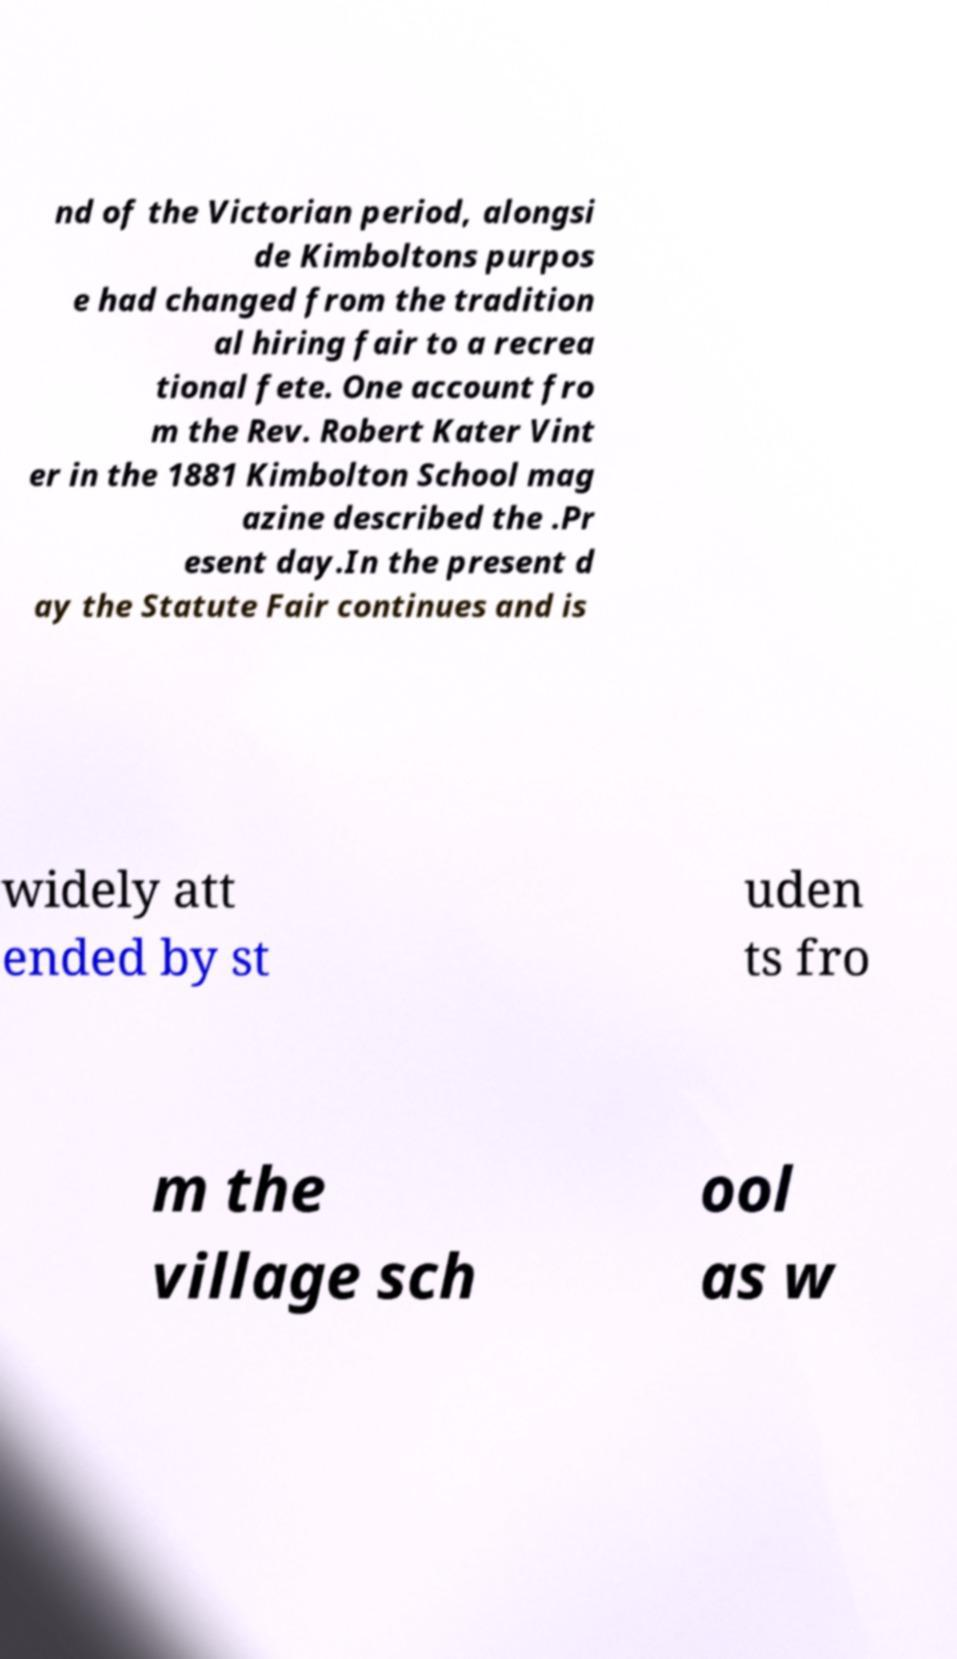Could you extract and type out the text from this image? nd of the Victorian period, alongsi de Kimboltons purpos e had changed from the tradition al hiring fair to a recrea tional fete. One account fro m the Rev. Robert Kater Vint er in the 1881 Kimbolton School mag azine described the .Pr esent day.In the present d ay the Statute Fair continues and is widely att ended by st uden ts fro m the village sch ool as w 